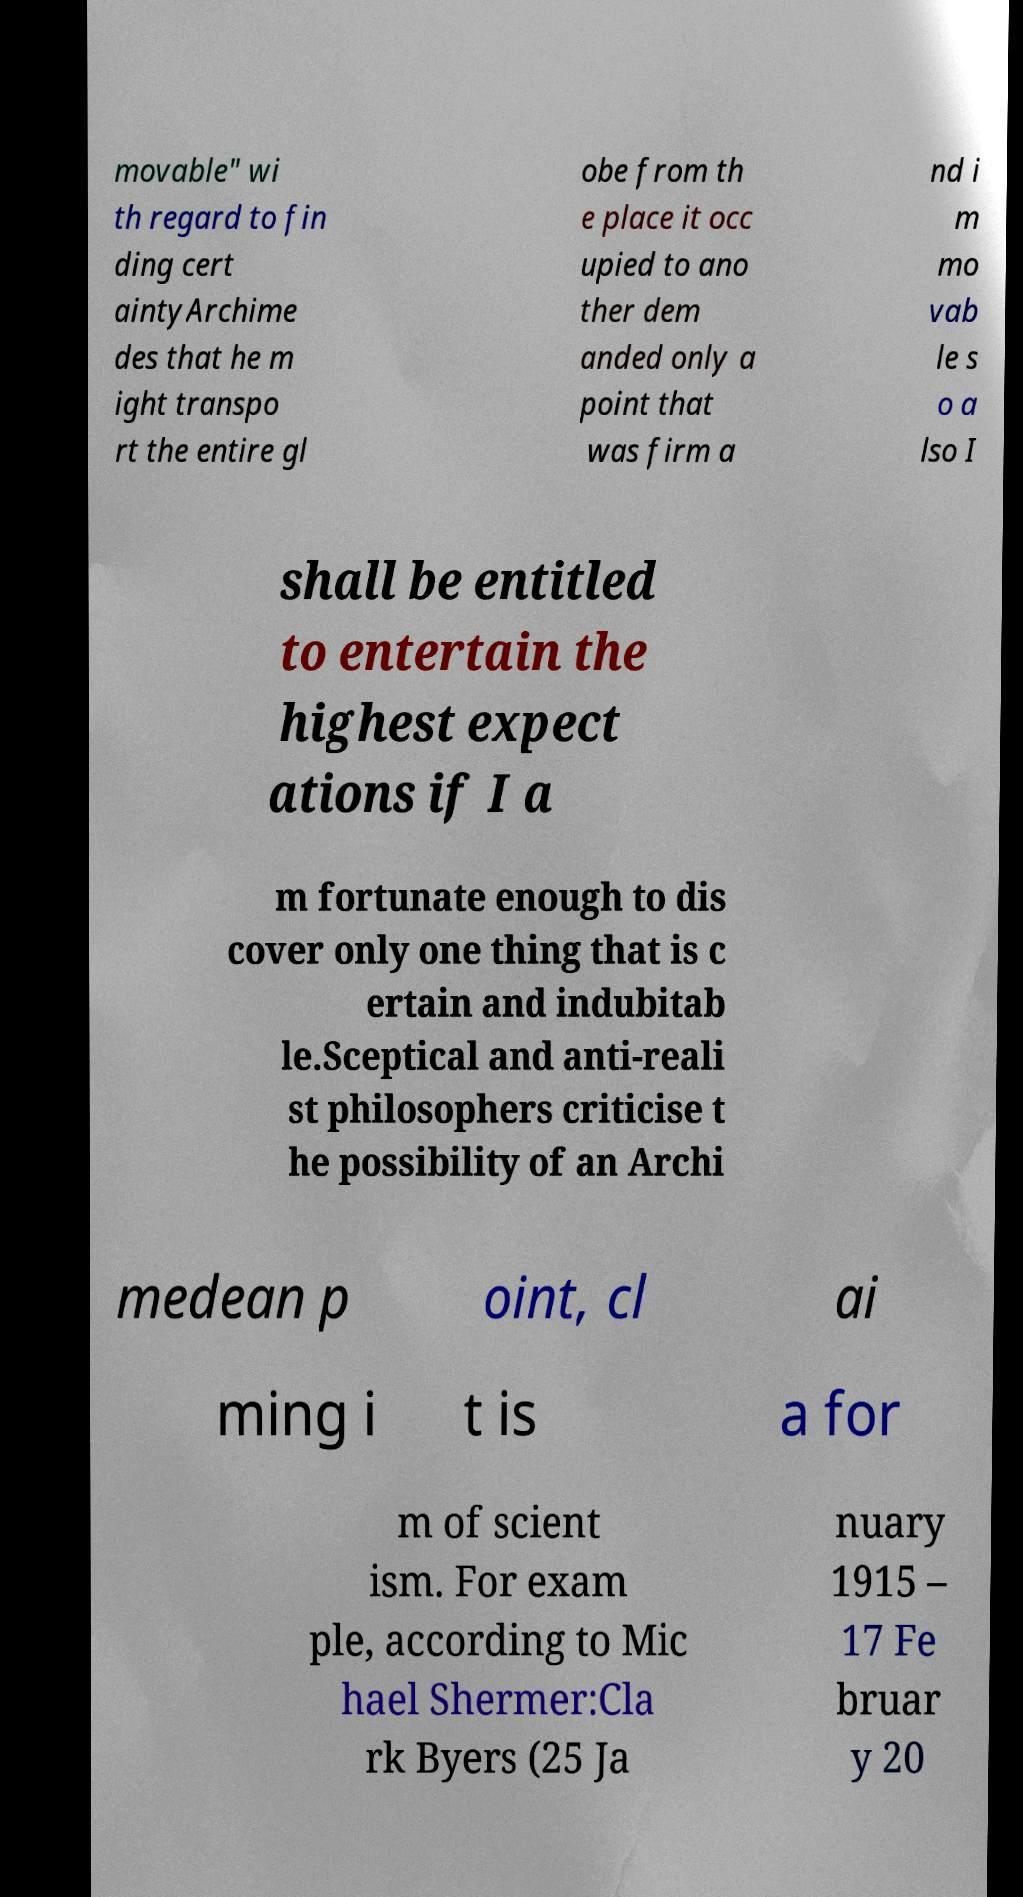Could you extract and type out the text from this image? movable" wi th regard to fin ding cert aintyArchime des that he m ight transpo rt the entire gl obe from th e place it occ upied to ano ther dem anded only a point that was firm a nd i m mo vab le s o a lso I shall be entitled to entertain the highest expect ations if I a m fortunate enough to dis cover only one thing that is c ertain and indubitab le.Sceptical and anti-reali st philosophers criticise t he possibility of an Archi medean p oint, cl ai ming i t is a for m of scient ism. For exam ple, according to Mic hael Shermer:Cla rk Byers (25 Ja nuary 1915 – 17 Fe bruar y 20 